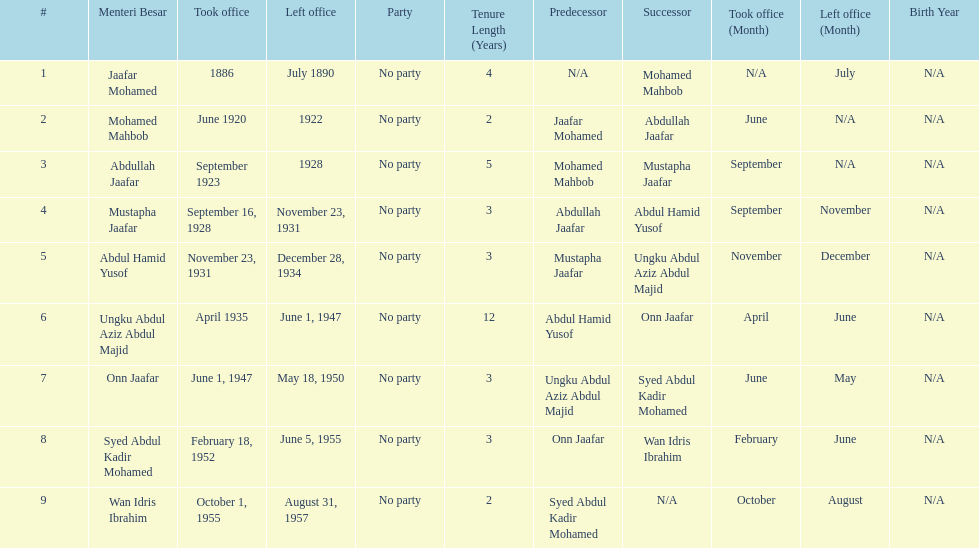What is the number of menteri besar that served 4 or more years? 3. 